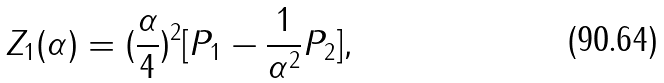<formula> <loc_0><loc_0><loc_500><loc_500>Z _ { 1 } ( \alpha ) = ( \frac { \alpha } { 4 } ) ^ { 2 } [ P _ { 1 } - \frac { 1 } { \alpha ^ { 2 } } P _ { 2 } ] ,</formula> 